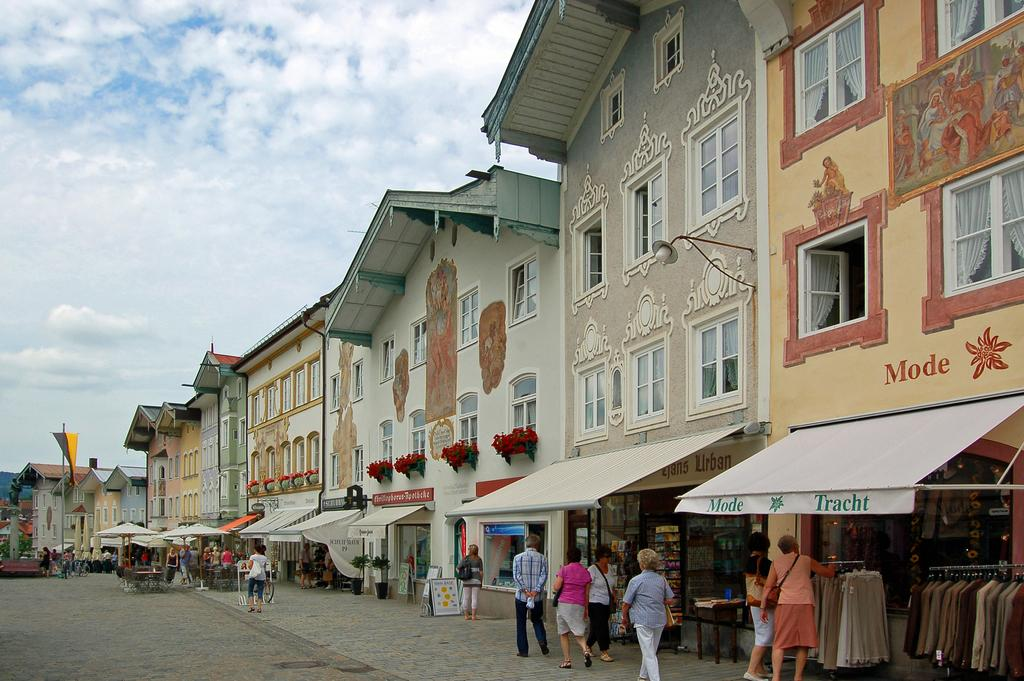How many people are in the image? There is a group of people in the image. What are the people doing in the image? The people are walking in the image. What can be seen in the background of the image? There are stalls, buildings, and windows visible in the image. What is the color of the sky in the image? The sky is blue and white in color. What is the effect of the size of the buildings on the people's walking speed in the image? There is no information provided about the size of the buildings or their effect on the people's walking speed in the image. 